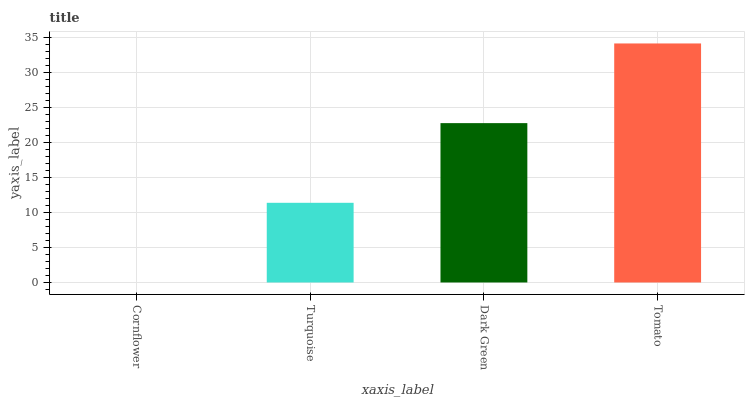Is Turquoise the minimum?
Answer yes or no. No. Is Turquoise the maximum?
Answer yes or no. No. Is Turquoise greater than Cornflower?
Answer yes or no. Yes. Is Cornflower less than Turquoise?
Answer yes or no. Yes. Is Cornflower greater than Turquoise?
Answer yes or no. No. Is Turquoise less than Cornflower?
Answer yes or no. No. Is Dark Green the high median?
Answer yes or no. Yes. Is Turquoise the low median?
Answer yes or no. Yes. Is Cornflower the high median?
Answer yes or no. No. Is Tomato the low median?
Answer yes or no. No. 